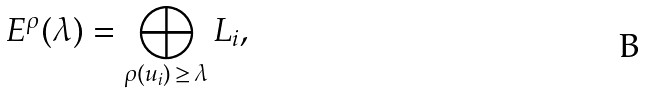<formula> <loc_0><loc_0><loc_500><loc_500>E ^ { \rho } ( \lambda ) = \bigoplus _ { \rho ( u _ { i } ) \, \geq \, \lambda } L _ { i } ,</formula> 